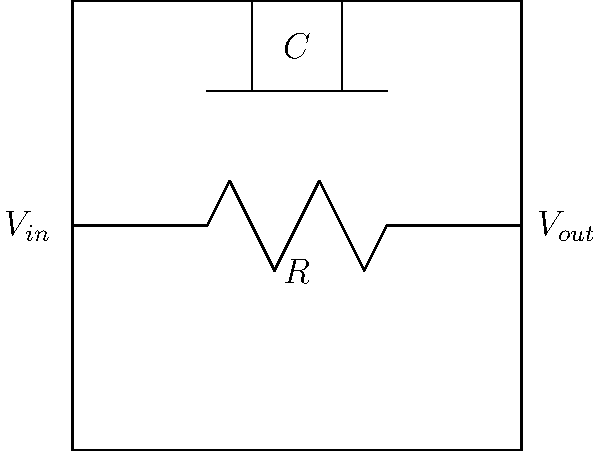In the given RC circuit diagram, what is the relationship between the input voltage ($V_{in}$) and output voltage ($V_{out}$) at high frequencies? Assume the capacitor is fully charged. To understand the relationship between $V_{in}$ and $V_{out}$ at high frequencies, let's follow these steps:

1. Analyze the circuit components:
   - The circuit consists of a resistor (R) and a capacitor (C) in series.
   - The input voltage ($V_{in}$) is applied across both components.
   - The output voltage ($V_{out}$) is measured across the capacitor.

2. Consider the behavior of capacitors at high frequencies:
   - At high frequencies, capacitors act like short circuits.
   - This means that the impedance of the capacitor approaches zero as frequency increases.

3. Voltage division in the circuit:
   - As the capacitor's impedance approaches zero, most of the voltage drop occurs across the resistor.
   - The voltage across the capacitor (which is $V_{out}$) becomes very small.

4. Relationship between $V_{in}$ and $V_{out}$:
   - As frequency approaches infinity, $V_{out}$ approaches zero.
   - This means that $V_{out} \ll V_{in}$ at high frequencies.

5. Function of the circuit:
   - This circuit acts as a low-pass filter, allowing low-frequency signals to pass through while attenuating high-frequency signals.

Therefore, at high frequencies, the output voltage ($V_{out}$) is much smaller than the input voltage ($V_{in}$), approaching zero as frequency increases.
Answer: $V_{out} \ll V_{in}$ 